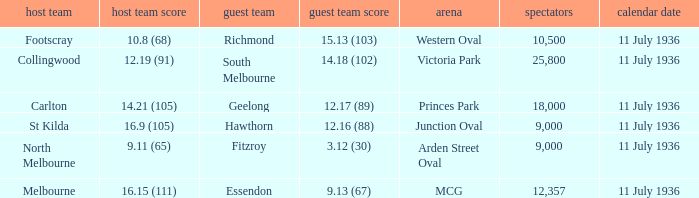What Away team got a team score of 12.16 (88)? Hawthorn. 